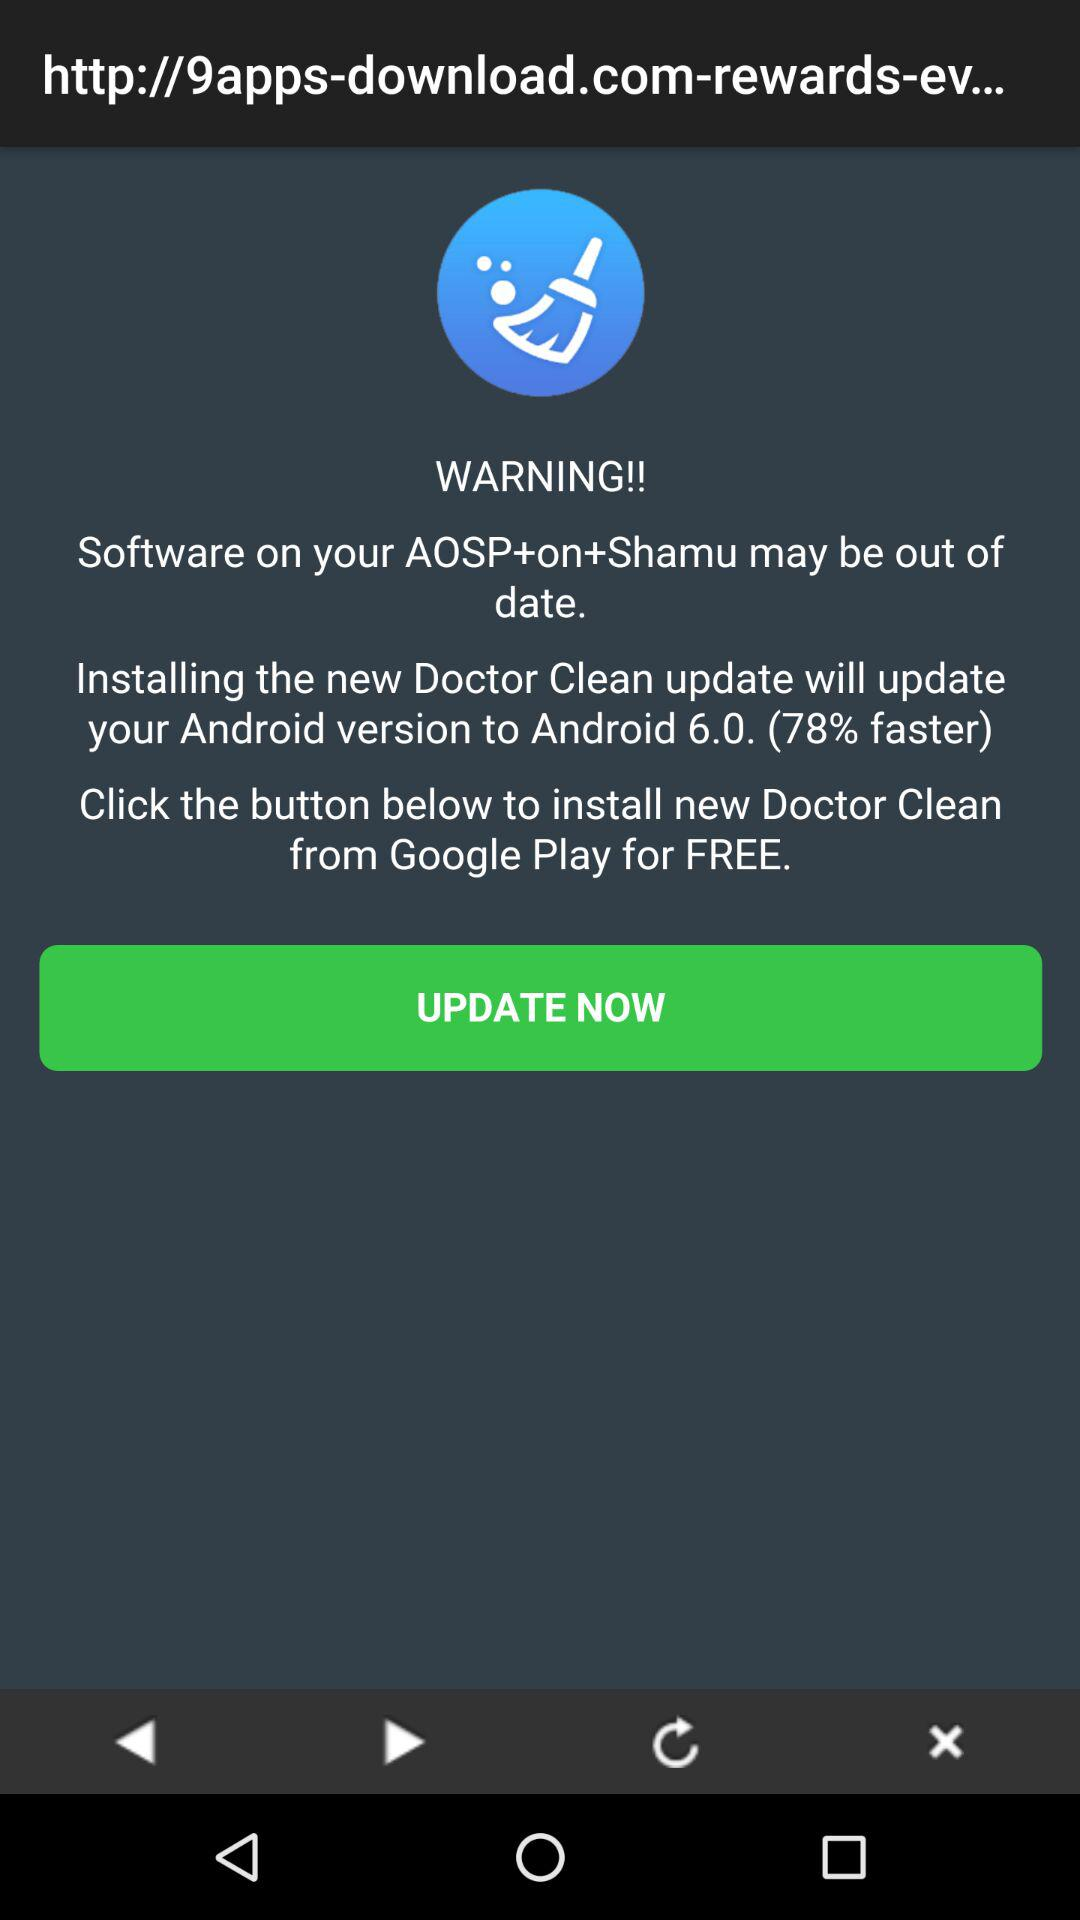What percentage faster is the new version? The new version is 78% faster. 